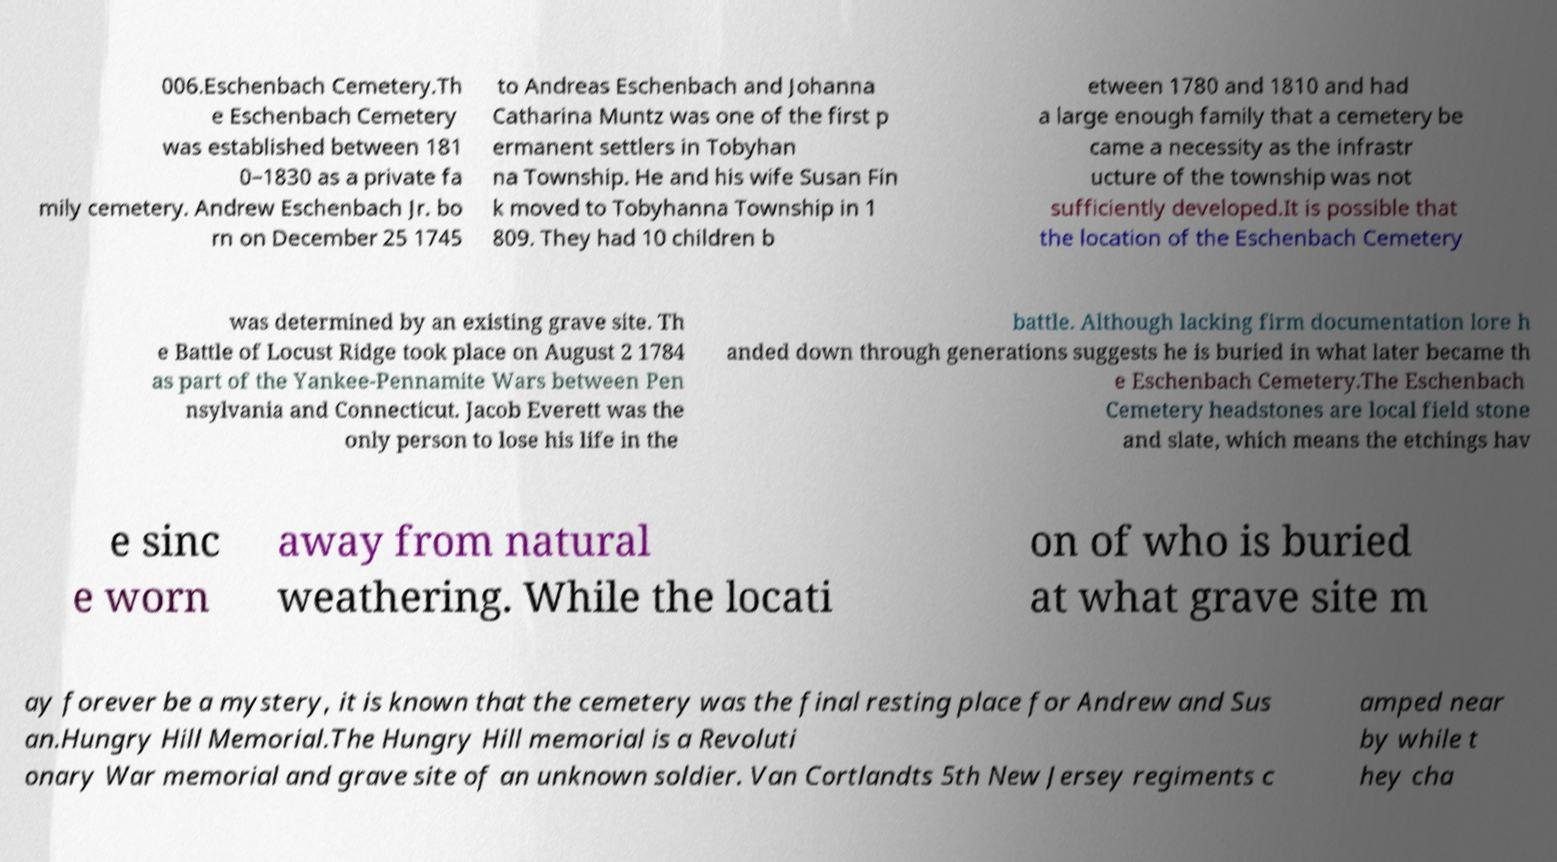Can you read and provide the text displayed in the image?This photo seems to have some interesting text. Can you extract and type it out for me? 006.Eschenbach Cemetery.Th e Eschenbach Cemetery was established between 181 0–1830 as a private fa mily cemetery. Andrew Eschenbach Jr. bo rn on December 25 1745 to Andreas Eschenbach and Johanna Catharina Muntz was one of the first p ermanent settlers in Tobyhan na Township. He and his wife Susan Fin k moved to Tobyhanna Township in 1 809. They had 10 children b etween 1780 and 1810 and had a large enough family that a cemetery be came a necessity as the infrastr ucture of the township was not sufficiently developed.It is possible that the location of the Eschenbach Cemetery was determined by an existing grave site. Th e Battle of Locust Ridge took place on August 2 1784 as part of the Yankee-Pennamite Wars between Pen nsylvania and Connecticut. Jacob Everett was the only person to lose his life in the battle. Although lacking firm documentation lore h anded down through generations suggests he is buried in what later became th e Eschenbach Cemetery.The Eschenbach Cemetery headstones are local field stone and slate, which means the etchings hav e sinc e worn away from natural weathering. While the locati on of who is buried at what grave site m ay forever be a mystery, it is known that the cemetery was the final resting place for Andrew and Sus an.Hungry Hill Memorial.The Hungry Hill memorial is a Revoluti onary War memorial and grave site of an unknown soldier. Van Cortlandts 5th New Jersey regiments c amped near by while t hey cha 